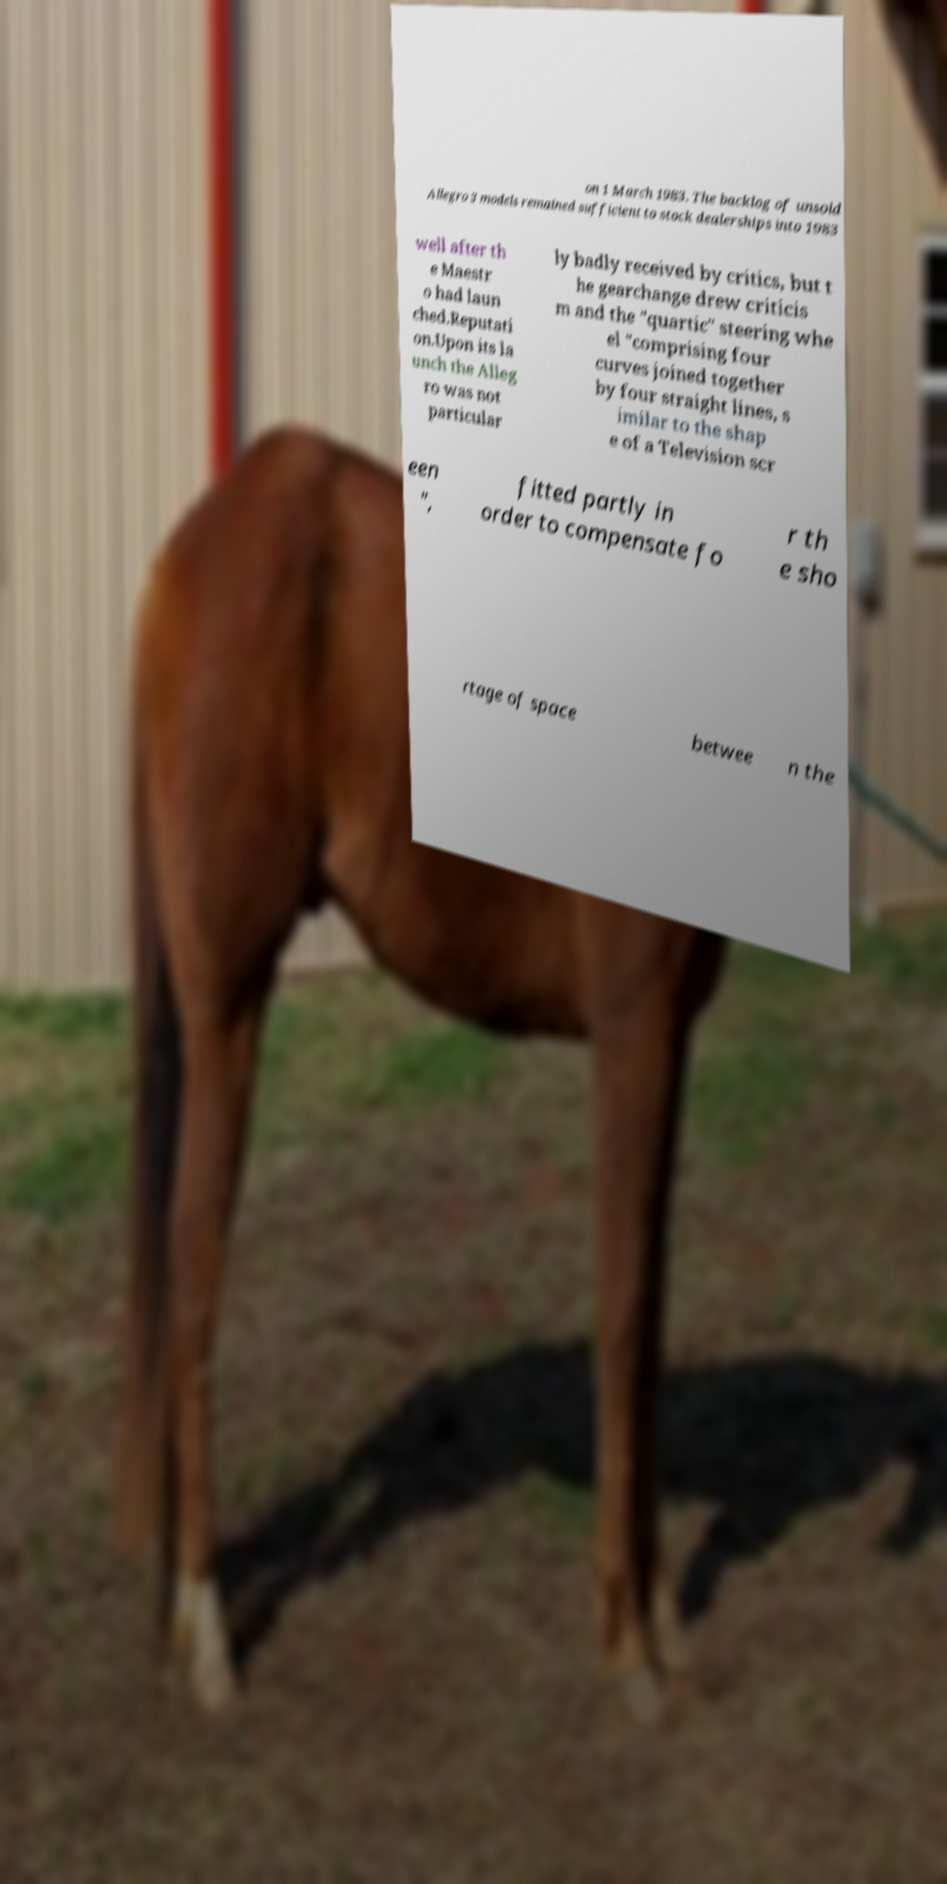Please identify and transcribe the text found in this image. on 1 March 1983. The backlog of unsold Allegro 3 models remained sufficient to stock dealerships into 1983 well after th e Maestr o had laun ched.Reputati on.Upon its la unch the Alleg ro was not particular ly badly received by critics, but t he gearchange drew criticis m and the "quartic" steering whe el "comprising four curves joined together by four straight lines, s imilar to the shap e of a Television scr een ", fitted partly in order to compensate fo r th e sho rtage of space betwee n the 